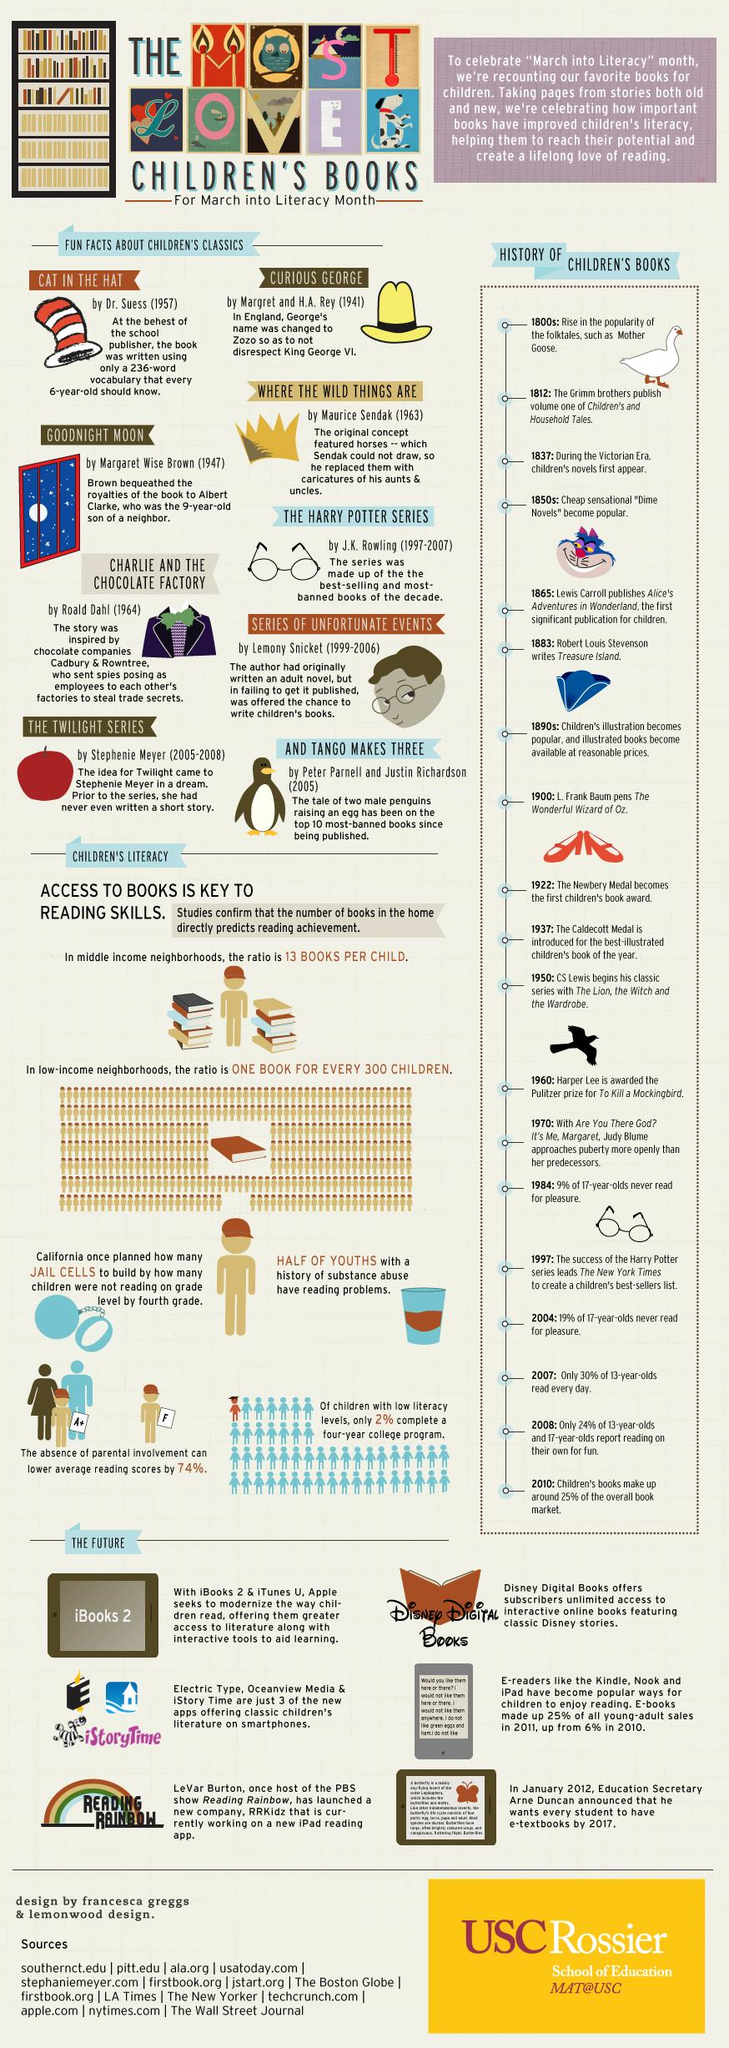Outline some significant characteristics in this image. The story of Alice in Wonderland was first published in 1865. The book that contained words that children aged six were familiar with was "The Cat in the Hat. 